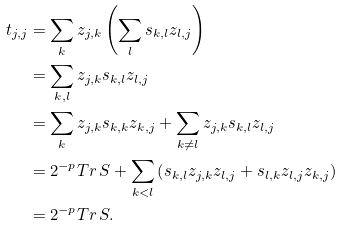<formula> <loc_0><loc_0><loc_500><loc_500>t _ { j , j } & = \sum _ { k } z _ { j , k } \left ( \sum _ { l } s _ { k , l } z _ { l , j } \right ) \\ & = \sum _ { k , l } z _ { j , k } s _ { k , l } z _ { l , j } \\ & = \sum _ { k } z _ { j , k } s _ { k , k } z _ { k , j } + \sum _ { k \neq l } z _ { j , k } s _ { k , l } z _ { l , j } \\ & = 2 ^ { - p } { T r \, } S + \sum _ { k < l } \left ( s _ { k , l } z _ { j , k } z _ { l , j } + s _ { l , k } z _ { l , j } z _ { k , j } \right ) \\ & = 2 ^ { - p } { T r \, } S .</formula> 